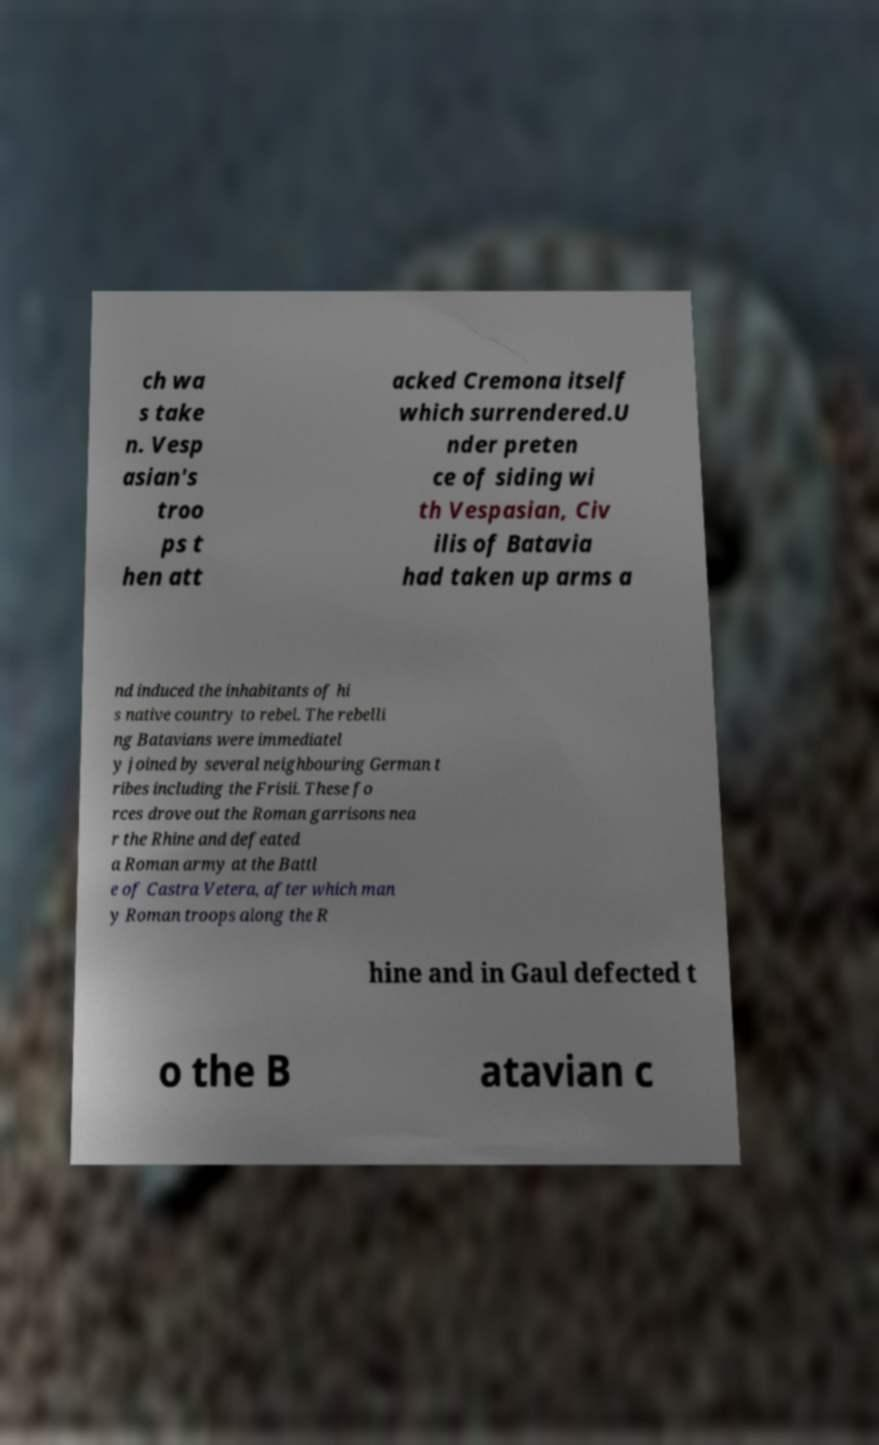Could you assist in decoding the text presented in this image and type it out clearly? ch wa s take n. Vesp asian's troo ps t hen att acked Cremona itself which surrendered.U nder preten ce of siding wi th Vespasian, Civ ilis of Batavia had taken up arms a nd induced the inhabitants of hi s native country to rebel. The rebelli ng Batavians were immediatel y joined by several neighbouring German t ribes including the Frisii. These fo rces drove out the Roman garrisons nea r the Rhine and defeated a Roman army at the Battl e of Castra Vetera, after which man y Roman troops along the R hine and in Gaul defected t o the B atavian c 